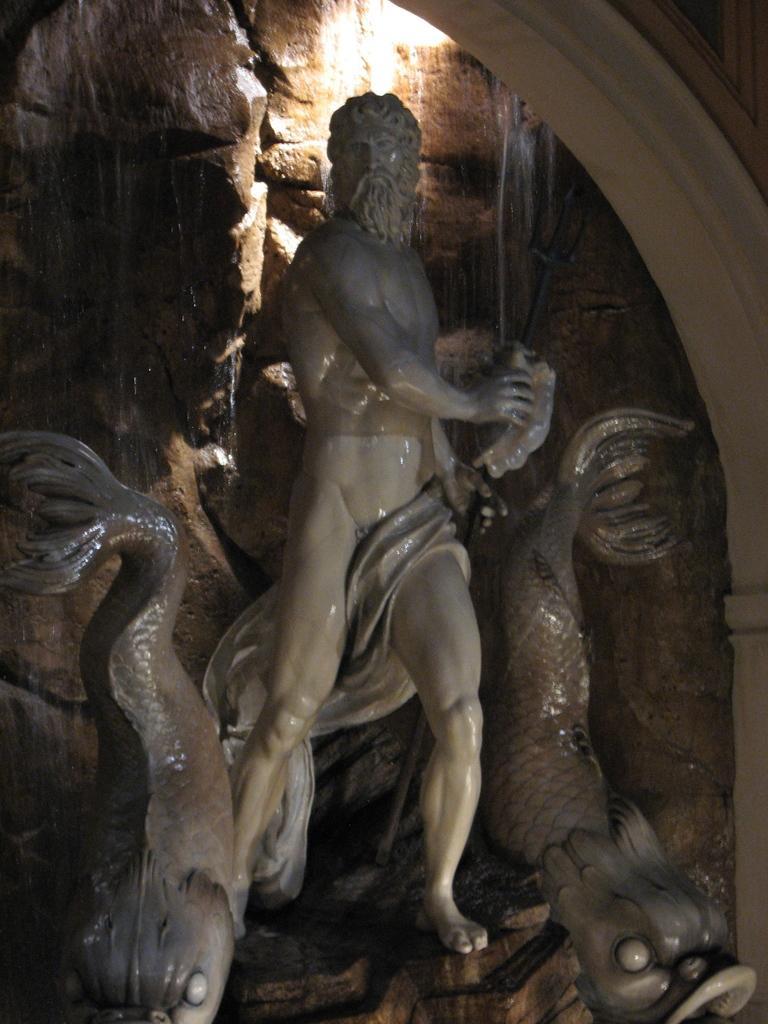Can you describe this image briefly? In the image there is a statue of a naked man with fish statue on either side of him and behind it there is stone wall. 